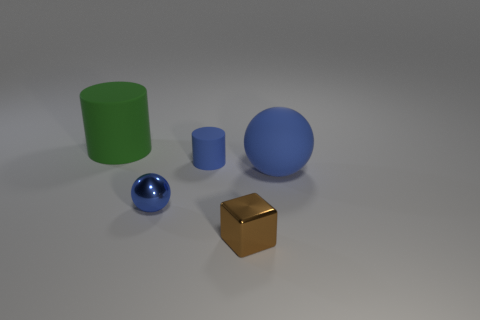Add 5 large brown rubber blocks. How many objects exist? 10 Subtract all blocks. How many objects are left? 4 Subtract all metal cubes. Subtract all tiny cubes. How many objects are left? 3 Add 2 big green rubber cylinders. How many big green rubber cylinders are left? 3 Add 5 big blue rubber cylinders. How many big blue rubber cylinders exist? 5 Subtract 1 green cylinders. How many objects are left? 4 